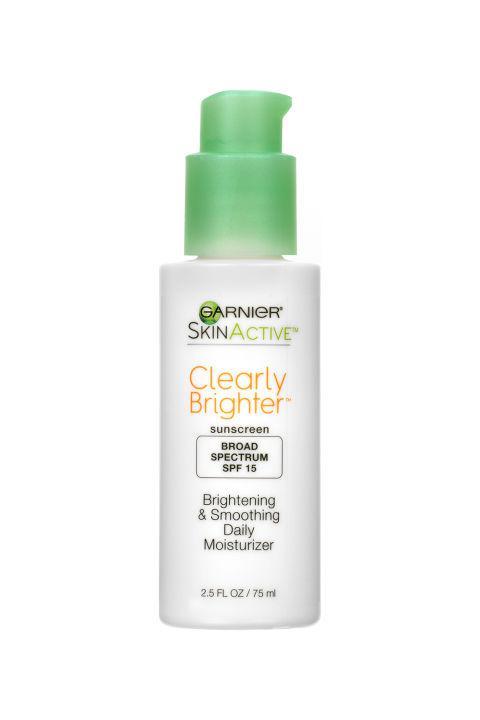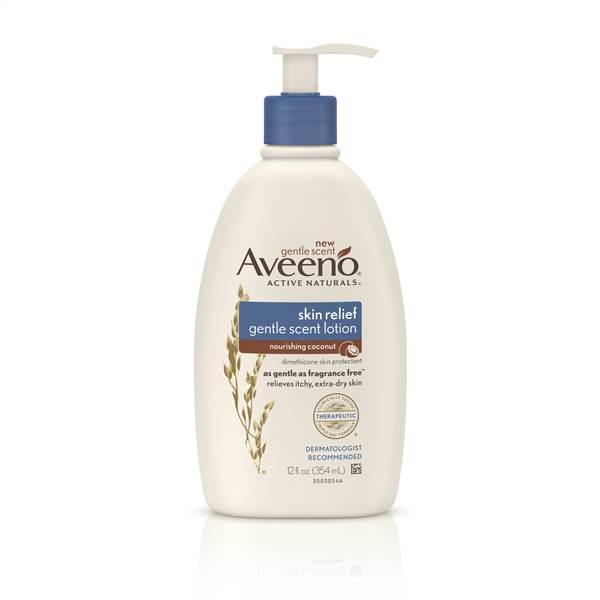The first image is the image on the left, the second image is the image on the right. For the images displayed, is the sentence "Both bottles have a pump-style dispenser on top." factually correct? Answer yes or no. Yes. The first image is the image on the left, the second image is the image on the right. Analyze the images presented: Is the assertion "There is at most, 1 lotion bottle with a green cap." valid? Answer yes or no. Yes. 